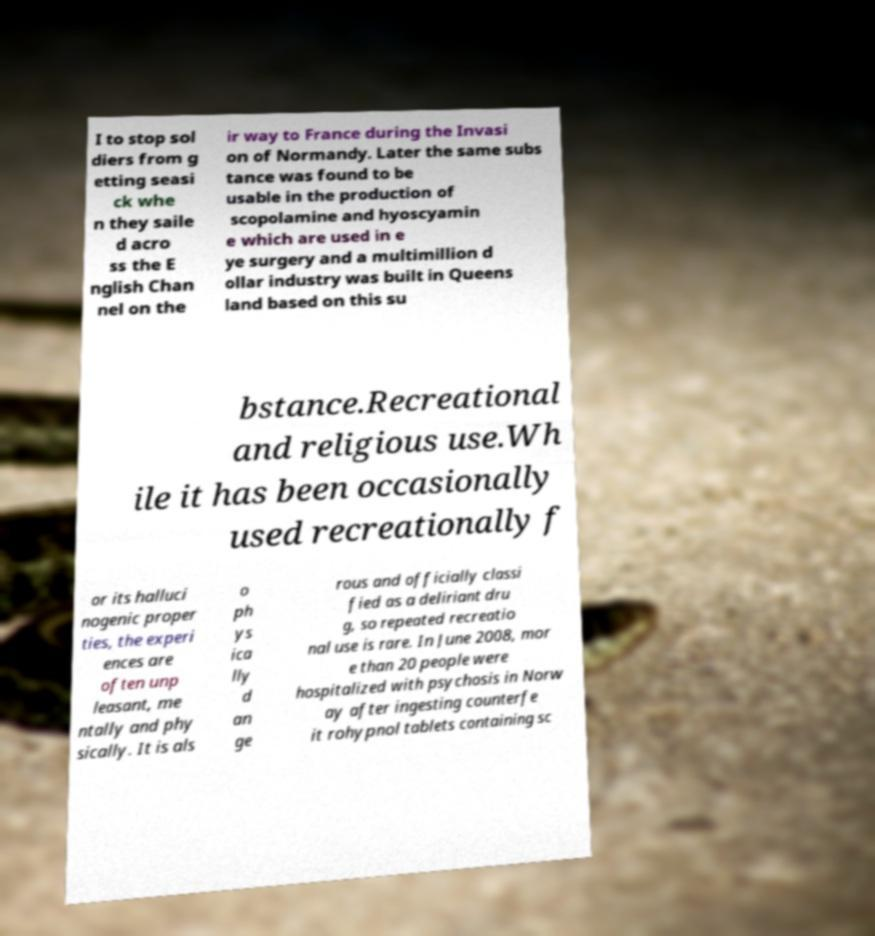Please identify and transcribe the text found in this image. I to stop sol diers from g etting seasi ck whe n they saile d acro ss the E nglish Chan nel on the ir way to France during the Invasi on of Normandy. Later the same subs tance was found to be usable in the production of scopolamine and hyoscyamin e which are used in e ye surgery and a multimillion d ollar industry was built in Queens land based on this su bstance.Recreational and religious use.Wh ile it has been occasionally used recreationally f or its halluci nogenic proper ties, the experi ences are often unp leasant, me ntally and phy sically. It is als o ph ys ica lly d an ge rous and officially classi fied as a deliriant dru g, so repeated recreatio nal use is rare. In June 2008, mor e than 20 people were hospitalized with psychosis in Norw ay after ingesting counterfe it rohypnol tablets containing sc 